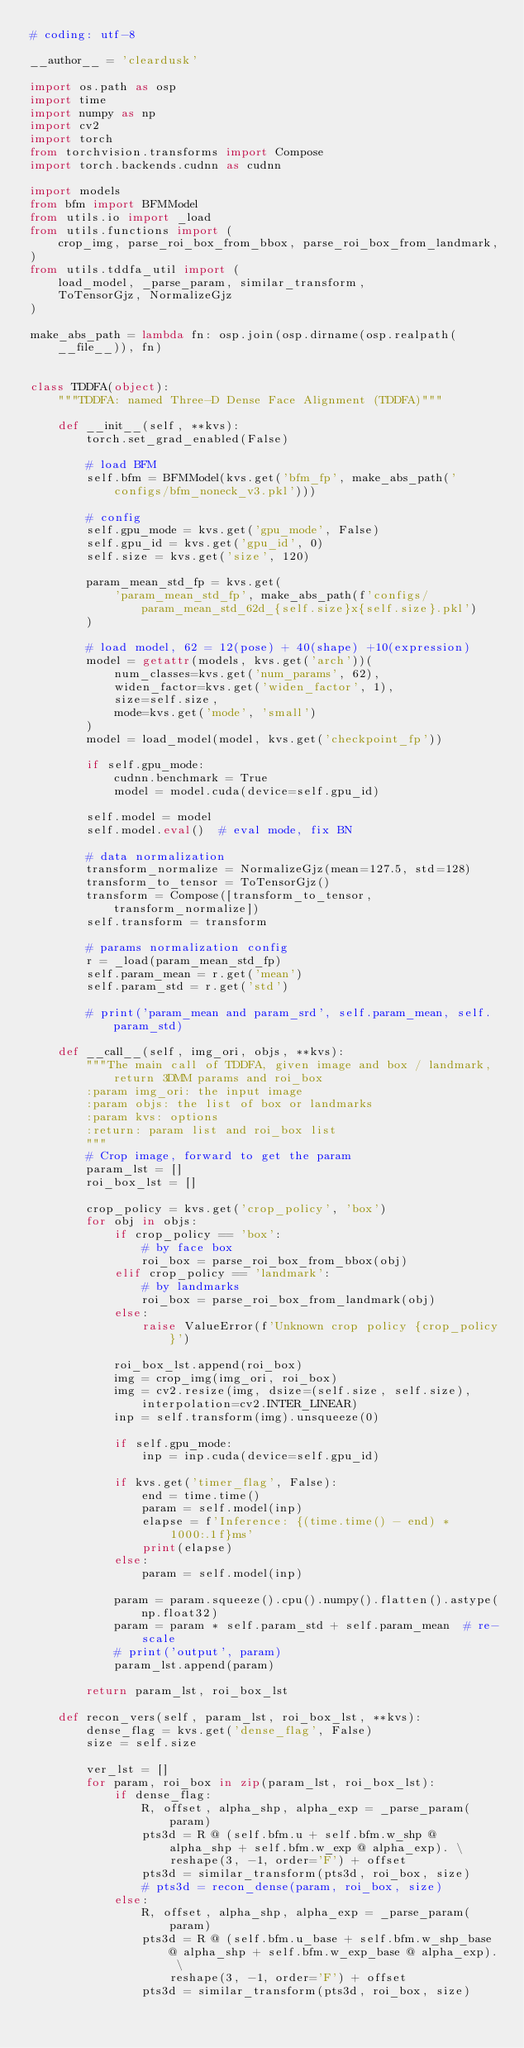<code> <loc_0><loc_0><loc_500><loc_500><_Python_># coding: utf-8

__author__ = 'cleardusk'

import os.path as osp
import time
import numpy as np
import cv2
import torch
from torchvision.transforms import Compose
import torch.backends.cudnn as cudnn

import models
from bfm import BFMModel
from utils.io import _load
from utils.functions import (
    crop_img, parse_roi_box_from_bbox, parse_roi_box_from_landmark,
)
from utils.tddfa_util import (
    load_model, _parse_param, similar_transform,
    ToTensorGjz, NormalizeGjz
)

make_abs_path = lambda fn: osp.join(osp.dirname(osp.realpath(__file__)), fn)


class TDDFA(object):
    """TDDFA: named Three-D Dense Face Alignment (TDDFA)"""

    def __init__(self, **kvs):
        torch.set_grad_enabled(False)

        # load BFM
        self.bfm = BFMModel(kvs.get('bfm_fp', make_abs_path('configs/bfm_noneck_v3.pkl')))

        # config
        self.gpu_mode = kvs.get('gpu_mode', False)
        self.gpu_id = kvs.get('gpu_id', 0)
        self.size = kvs.get('size', 120)

        param_mean_std_fp = kvs.get(
            'param_mean_std_fp', make_abs_path(f'configs/param_mean_std_62d_{self.size}x{self.size}.pkl')
        )

        # load model, 62 = 12(pose) + 40(shape) +10(expression)
        model = getattr(models, kvs.get('arch'))(
            num_classes=kvs.get('num_params', 62),
            widen_factor=kvs.get('widen_factor', 1),
            size=self.size,
            mode=kvs.get('mode', 'small')
        )
        model = load_model(model, kvs.get('checkpoint_fp'))

        if self.gpu_mode:
            cudnn.benchmark = True
            model = model.cuda(device=self.gpu_id)

        self.model = model
        self.model.eval()  # eval mode, fix BN

        # data normalization
        transform_normalize = NormalizeGjz(mean=127.5, std=128)
        transform_to_tensor = ToTensorGjz()
        transform = Compose([transform_to_tensor, transform_normalize])
        self.transform = transform

        # params normalization config
        r = _load(param_mean_std_fp)
        self.param_mean = r.get('mean')
        self.param_std = r.get('std')

        # print('param_mean and param_srd', self.param_mean, self.param_std)

    def __call__(self, img_ori, objs, **kvs):
        """The main call of TDDFA, given image and box / landmark, return 3DMM params and roi_box
        :param img_ori: the input image
        :param objs: the list of box or landmarks
        :param kvs: options
        :return: param list and roi_box list
        """
        # Crop image, forward to get the param
        param_lst = []
        roi_box_lst = []

        crop_policy = kvs.get('crop_policy', 'box')
        for obj in objs:
            if crop_policy == 'box':
                # by face box
                roi_box = parse_roi_box_from_bbox(obj)
            elif crop_policy == 'landmark':
                # by landmarks
                roi_box = parse_roi_box_from_landmark(obj)
            else:
                raise ValueError(f'Unknown crop policy {crop_policy}')

            roi_box_lst.append(roi_box)
            img = crop_img(img_ori, roi_box)
            img = cv2.resize(img, dsize=(self.size, self.size), interpolation=cv2.INTER_LINEAR)
            inp = self.transform(img).unsqueeze(0)

            if self.gpu_mode:
                inp = inp.cuda(device=self.gpu_id)

            if kvs.get('timer_flag', False):
                end = time.time()
                param = self.model(inp)
                elapse = f'Inference: {(time.time() - end) * 1000:.1f}ms'
                print(elapse)
            else:
                param = self.model(inp)

            param = param.squeeze().cpu().numpy().flatten().astype(np.float32)
            param = param * self.param_std + self.param_mean  # re-scale
            # print('output', param)
            param_lst.append(param)

        return param_lst, roi_box_lst

    def recon_vers(self, param_lst, roi_box_lst, **kvs):
        dense_flag = kvs.get('dense_flag', False)
        size = self.size

        ver_lst = []
        for param, roi_box in zip(param_lst, roi_box_lst):
            if dense_flag:
                R, offset, alpha_shp, alpha_exp = _parse_param(param)
                pts3d = R @ (self.bfm.u + self.bfm.w_shp @ alpha_shp + self.bfm.w_exp @ alpha_exp). \
                    reshape(3, -1, order='F') + offset
                pts3d = similar_transform(pts3d, roi_box, size)
                # pts3d = recon_dense(param, roi_box, size)
            else:
                R, offset, alpha_shp, alpha_exp = _parse_param(param)
                pts3d = R @ (self.bfm.u_base + self.bfm.w_shp_base @ alpha_shp + self.bfm.w_exp_base @ alpha_exp). \
                    reshape(3, -1, order='F') + offset
                pts3d = similar_transform(pts3d, roi_box, size)</code> 